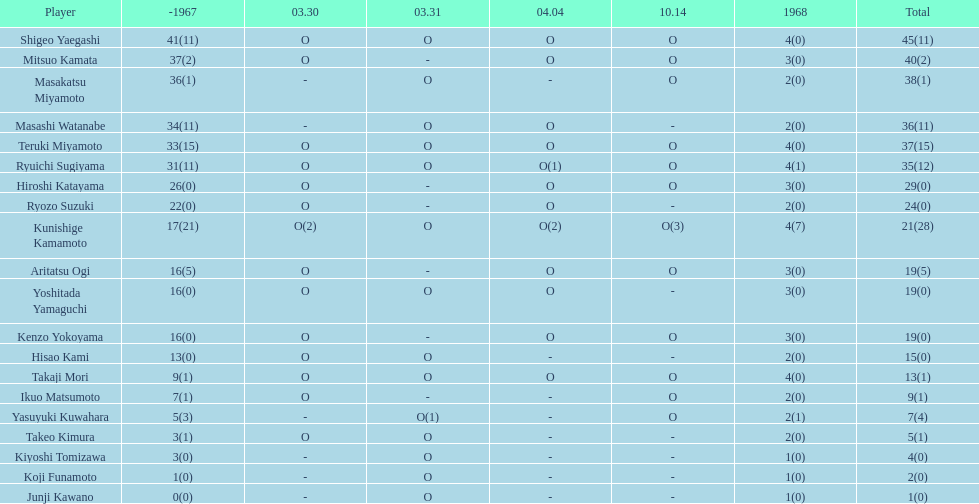How many more total appearances did shigeo yaegashi have than mitsuo kamata? 5. 